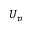<formula> <loc_0><loc_0><loc_500><loc_500>U _ { p }</formula> 